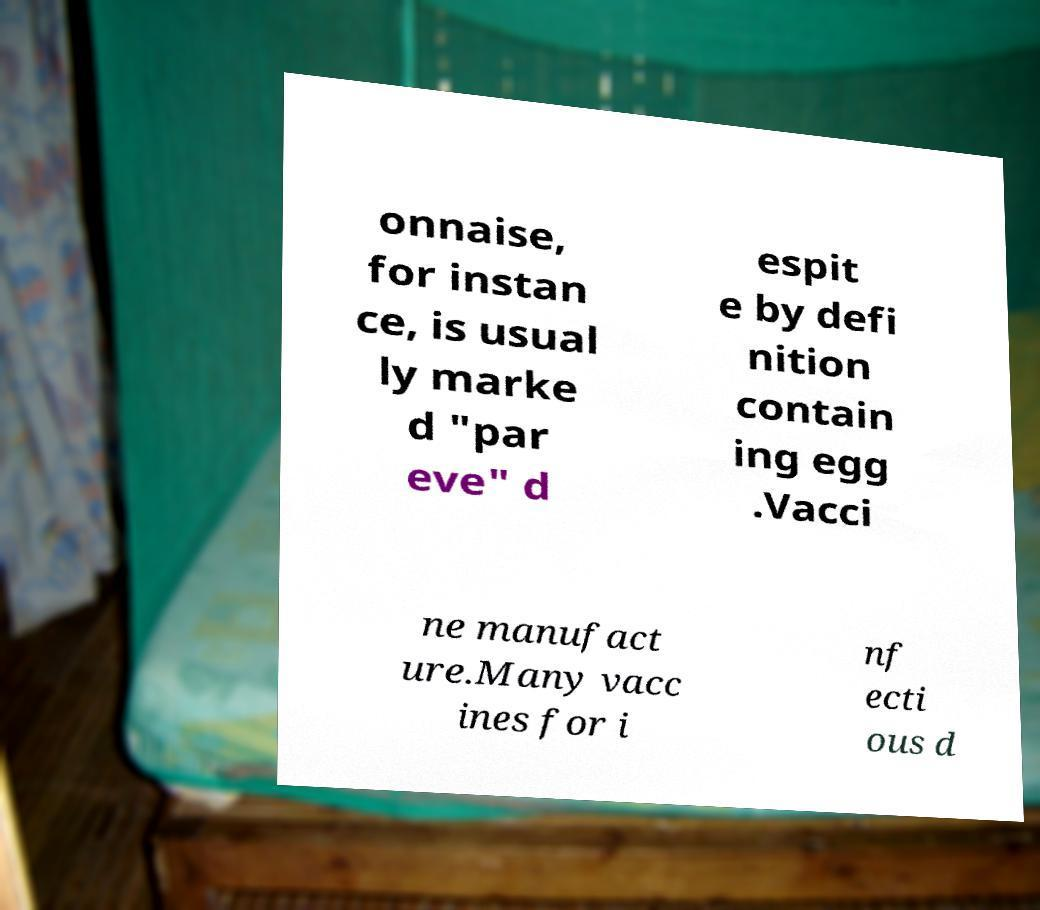Can you accurately transcribe the text from the provided image for me? onnaise, for instan ce, is usual ly marke d "par eve" d espit e by defi nition contain ing egg .Vacci ne manufact ure.Many vacc ines for i nf ecti ous d 